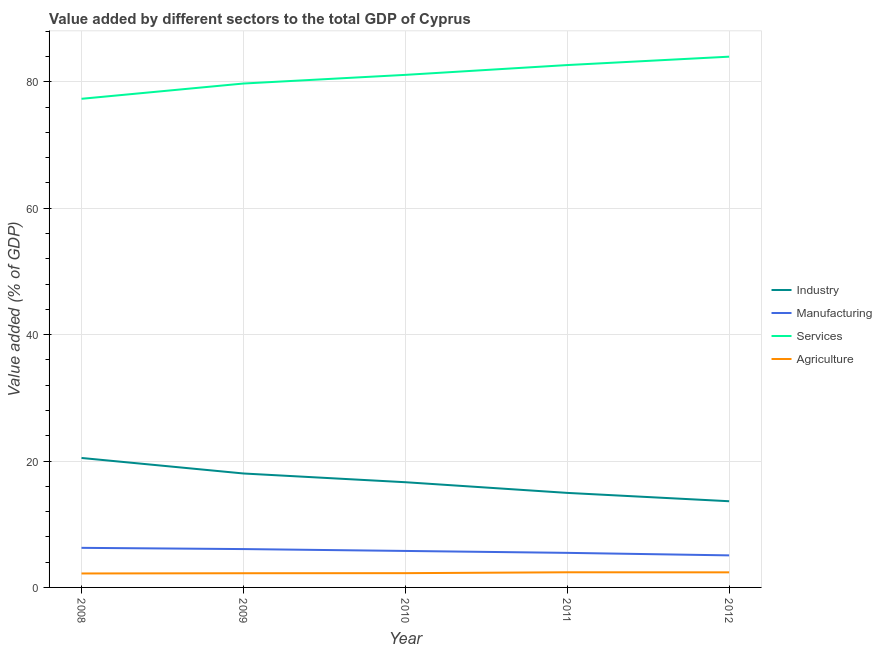How many different coloured lines are there?
Provide a short and direct response. 4. Is the number of lines equal to the number of legend labels?
Your answer should be compact. Yes. What is the value added by industrial sector in 2011?
Offer a terse response. 14.96. Across all years, what is the maximum value added by industrial sector?
Keep it short and to the point. 20.48. Across all years, what is the minimum value added by services sector?
Ensure brevity in your answer.  77.31. What is the total value added by services sector in the graph?
Make the answer very short. 404.76. What is the difference between the value added by services sector in 2011 and that in 2012?
Ensure brevity in your answer.  -1.33. What is the difference between the value added by services sector in 2009 and the value added by manufacturing sector in 2012?
Offer a very short reply. 74.65. What is the average value added by industrial sector per year?
Provide a succinct answer. 16.75. In the year 2008, what is the difference between the value added by manufacturing sector and value added by services sector?
Ensure brevity in your answer.  -71.05. What is the ratio of the value added by industrial sector in 2008 to that in 2012?
Make the answer very short. 1.5. What is the difference between the highest and the second highest value added by industrial sector?
Your answer should be very brief. 2.45. What is the difference between the highest and the lowest value added by manufacturing sector?
Offer a very short reply. 1.19. In how many years, is the value added by industrial sector greater than the average value added by industrial sector taken over all years?
Keep it short and to the point. 2. Is it the case that in every year, the sum of the value added by industrial sector and value added by manufacturing sector is greater than the value added by services sector?
Provide a short and direct response. No. Is the value added by manufacturing sector strictly greater than the value added by industrial sector over the years?
Provide a short and direct response. No. Is the value added by manufacturing sector strictly less than the value added by agricultural sector over the years?
Your answer should be very brief. No. How many lines are there?
Provide a short and direct response. 4. How many years are there in the graph?
Your answer should be compact. 5. What is the difference between two consecutive major ticks on the Y-axis?
Ensure brevity in your answer.  20. Does the graph contain grids?
Your answer should be very brief. Yes. Where does the legend appear in the graph?
Ensure brevity in your answer.  Center right. How many legend labels are there?
Provide a short and direct response. 4. What is the title of the graph?
Offer a very short reply. Value added by different sectors to the total GDP of Cyprus. What is the label or title of the X-axis?
Give a very brief answer. Year. What is the label or title of the Y-axis?
Your response must be concise. Value added (% of GDP). What is the Value added (% of GDP) in Industry in 2008?
Offer a terse response. 20.48. What is the Value added (% of GDP) of Manufacturing in 2008?
Give a very brief answer. 6.26. What is the Value added (% of GDP) in Services in 2008?
Give a very brief answer. 77.31. What is the Value added (% of GDP) of Agriculture in 2008?
Provide a short and direct response. 2.21. What is the Value added (% of GDP) of Industry in 2009?
Your answer should be compact. 18.03. What is the Value added (% of GDP) in Manufacturing in 2009?
Provide a short and direct response. 6.07. What is the Value added (% of GDP) of Services in 2009?
Your answer should be very brief. 79.73. What is the Value added (% of GDP) in Agriculture in 2009?
Provide a succinct answer. 2.24. What is the Value added (% of GDP) of Industry in 2010?
Give a very brief answer. 16.65. What is the Value added (% of GDP) in Manufacturing in 2010?
Make the answer very short. 5.77. What is the Value added (% of GDP) in Services in 2010?
Your answer should be very brief. 81.1. What is the Value added (% of GDP) in Agriculture in 2010?
Give a very brief answer. 2.26. What is the Value added (% of GDP) of Industry in 2011?
Provide a short and direct response. 14.96. What is the Value added (% of GDP) in Manufacturing in 2011?
Offer a very short reply. 5.47. What is the Value added (% of GDP) of Services in 2011?
Offer a very short reply. 82.65. What is the Value added (% of GDP) of Agriculture in 2011?
Your response must be concise. 2.4. What is the Value added (% of GDP) of Industry in 2012?
Your response must be concise. 13.64. What is the Value added (% of GDP) in Manufacturing in 2012?
Keep it short and to the point. 5.07. What is the Value added (% of GDP) of Services in 2012?
Your answer should be very brief. 83.98. What is the Value added (% of GDP) in Agriculture in 2012?
Ensure brevity in your answer.  2.39. Across all years, what is the maximum Value added (% of GDP) in Industry?
Give a very brief answer. 20.48. Across all years, what is the maximum Value added (% of GDP) in Manufacturing?
Keep it short and to the point. 6.26. Across all years, what is the maximum Value added (% of GDP) in Services?
Your answer should be very brief. 83.98. Across all years, what is the maximum Value added (% of GDP) of Agriculture?
Offer a very short reply. 2.4. Across all years, what is the minimum Value added (% of GDP) in Industry?
Your answer should be very brief. 13.64. Across all years, what is the minimum Value added (% of GDP) of Manufacturing?
Give a very brief answer. 5.07. Across all years, what is the minimum Value added (% of GDP) in Services?
Offer a terse response. 77.31. Across all years, what is the minimum Value added (% of GDP) of Agriculture?
Your answer should be very brief. 2.21. What is the total Value added (% of GDP) of Industry in the graph?
Provide a succinct answer. 83.75. What is the total Value added (% of GDP) in Manufacturing in the graph?
Make the answer very short. 28.65. What is the total Value added (% of GDP) in Services in the graph?
Keep it short and to the point. 404.76. What is the total Value added (% of GDP) in Agriculture in the graph?
Give a very brief answer. 11.49. What is the difference between the Value added (% of GDP) of Industry in 2008 and that in 2009?
Your answer should be compact. 2.45. What is the difference between the Value added (% of GDP) of Manufacturing in 2008 and that in 2009?
Give a very brief answer. 0.19. What is the difference between the Value added (% of GDP) of Services in 2008 and that in 2009?
Ensure brevity in your answer.  -2.42. What is the difference between the Value added (% of GDP) in Agriculture in 2008 and that in 2009?
Provide a short and direct response. -0.04. What is the difference between the Value added (% of GDP) in Industry in 2008 and that in 2010?
Your answer should be compact. 3.84. What is the difference between the Value added (% of GDP) of Manufacturing in 2008 and that in 2010?
Keep it short and to the point. 0.49. What is the difference between the Value added (% of GDP) in Services in 2008 and that in 2010?
Your response must be concise. -3.79. What is the difference between the Value added (% of GDP) in Agriculture in 2008 and that in 2010?
Make the answer very short. -0.05. What is the difference between the Value added (% of GDP) in Industry in 2008 and that in 2011?
Offer a very short reply. 5.53. What is the difference between the Value added (% of GDP) of Manufacturing in 2008 and that in 2011?
Make the answer very short. 0.79. What is the difference between the Value added (% of GDP) in Services in 2008 and that in 2011?
Offer a terse response. -5.34. What is the difference between the Value added (% of GDP) of Agriculture in 2008 and that in 2011?
Offer a very short reply. -0.19. What is the difference between the Value added (% of GDP) of Industry in 2008 and that in 2012?
Provide a succinct answer. 6.85. What is the difference between the Value added (% of GDP) in Manufacturing in 2008 and that in 2012?
Make the answer very short. 1.19. What is the difference between the Value added (% of GDP) in Services in 2008 and that in 2012?
Provide a short and direct response. -6.67. What is the difference between the Value added (% of GDP) in Agriculture in 2008 and that in 2012?
Keep it short and to the point. -0.18. What is the difference between the Value added (% of GDP) in Industry in 2009 and that in 2010?
Your answer should be very brief. 1.38. What is the difference between the Value added (% of GDP) of Manufacturing in 2009 and that in 2010?
Keep it short and to the point. 0.3. What is the difference between the Value added (% of GDP) of Services in 2009 and that in 2010?
Provide a short and direct response. -1.37. What is the difference between the Value added (% of GDP) of Agriculture in 2009 and that in 2010?
Provide a succinct answer. -0.01. What is the difference between the Value added (% of GDP) of Industry in 2009 and that in 2011?
Provide a short and direct response. 3.07. What is the difference between the Value added (% of GDP) in Manufacturing in 2009 and that in 2011?
Offer a terse response. 0.6. What is the difference between the Value added (% of GDP) in Services in 2009 and that in 2011?
Offer a very short reply. -2.92. What is the difference between the Value added (% of GDP) of Agriculture in 2009 and that in 2011?
Your response must be concise. -0.15. What is the difference between the Value added (% of GDP) of Industry in 2009 and that in 2012?
Ensure brevity in your answer.  4.39. What is the difference between the Value added (% of GDP) in Services in 2009 and that in 2012?
Give a very brief answer. -4.25. What is the difference between the Value added (% of GDP) in Agriculture in 2009 and that in 2012?
Make the answer very short. -0.14. What is the difference between the Value added (% of GDP) in Industry in 2010 and that in 2011?
Give a very brief answer. 1.69. What is the difference between the Value added (% of GDP) in Manufacturing in 2010 and that in 2011?
Your answer should be very brief. 0.3. What is the difference between the Value added (% of GDP) in Services in 2010 and that in 2011?
Provide a short and direct response. -1.55. What is the difference between the Value added (% of GDP) in Agriculture in 2010 and that in 2011?
Your response must be concise. -0.14. What is the difference between the Value added (% of GDP) of Industry in 2010 and that in 2012?
Keep it short and to the point. 3.01. What is the difference between the Value added (% of GDP) of Manufacturing in 2010 and that in 2012?
Give a very brief answer. 0.7. What is the difference between the Value added (% of GDP) of Services in 2010 and that in 2012?
Keep it short and to the point. -2.88. What is the difference between the Value added (% of GDP) of Agriculture in 2010 and that in 2012?
Make the answer very short. -0.13. What is the difference between the Value added (% of GDP) of Industry in 2011 and that in 2012?
Give a very brief answer. 1.32. What is the difference between the Value added (% of GDP) of Manufacturing in 2011 and that in 2012?
Provide a short and direct response. 0.4. What is the difference between the Value added (% of GDP) in Services in 2011 and that in 2012?
Your response must be concise. -1.33. What is the difference between the Value added (% of GDP) of Agriculture in 2011 and that in 2012?
Provide a short and direct response. 0.01. What is the difference between the Value added (% of GDP) in Industry in 2008 and the Value added (% of GDP) in Manufacturing in 2009?
Your answer should be compact. 14.41. What is the difference between the Value added (% of GDP) of Industry in 2008 and the Value added (% of GDP) of Services in 2009?
Provide a succinct answer. -59.24. What is the difference between the Value added (% of GDP) in Industry in 2008 and the Value added (% of GDP) in Agriculture in 2009?
Keep it short and to the point. 18.24. What is the difference between the Value added (% of GDP) in Manufacturing in 2008 and the Value added (% of GDP) in Services in 2009?
Make the answer very short. -73.46. What is the difference between the Value added (% of GDP) in Manufacturing in 2008 and the Value added (% of GDP) in Agriculture in 2009?
Provide a succinct answer. 4.02. What is the difference between the Value added (% of GDP) in Services in 2008 and the Value added (% of GDP) in Agriculture in 2009?
Give a very brief answer. 75.06. What is the difference between the Value added (% of GDP) of Industry in 2008 and the Value added (% of GDP) of Manufacturing in 2010?
Make the answer very short. 14.71. What is the difference between the Value added (% of GDP) in Industry in 2008 and the Value added (% of GDP) in Services in 2010?
Provide a succinct answer. -60.61. What is the difference between the Value added (% of GDP) of Industry in 2008 and the Value added (% of GDP) of Agriculture in 2010?
Provide a short and direct response. 18.23. What is the difference between the Value added (% of GDP) in Manufacturing in 2008 and the Value added (% of GDP) in Services in 2010?
Give a very brief answer. -74.83. What is the difference between the Value added (% of GDP) of Manufacturing in 2008 and the Value added (% of GDP) of Agriculture in 2010?
Provide a short and direct response. 4.01. What is the difference between the Value added (% of GDP) of Services in 2008 and the Value added (% of GDP) of Agriculture in 2010?
Provide a succinct answer. 75.05. What is the difference between the Value added (% of GDP) in Industry in 2008 and the Value added (% of GDP) in Manufacturing in 2011?
Give a very brief answer. 15.01. What is the difference between the Value added (% of GDP) of Industry in 2008 and the Value added (% of GDP) of Services in 2011?
Keep it short and to the point. -62.16. What is the difference between the Value added (% of GDP) of Industry in 2008 and the Value added (% of GDP) of Agriculture in 2011?
Your answer should be very brief. 18.09. What is the difference between the Value added (% of GDP) in Manufacturing in 2008 and the Value added (% of GDP) in Services in 2011?
Your response must be concise. -76.38. What is the difference between the Value added (% of GDP) in Manufacturing in 2008 and the Value added (% of GDP) in Agriculture in 2011?
Keep it short and to the point. 3.87. What is the difference between the Value added (% of GDP) of Services in 2008 and the Value added (% of GDP) of Agriculture in 2011?
Your answer should be very brief. 74.91. What is the difference between the Value added (% of GDP) in Industry in 2008 and the Value added (% of GDP) in Manufacturing in 2012?
Give a very brief answer. 15.41. What is the difference between the Value added (% of GDP) of Industry in 2008 and the Value added (% of GDP) of Services in 2012?
Provide a short and direct response. -63.49. What is the difference between the Value added (% of GDP) in Industry in 2008 and the Value added (% of GDP) in Agriculture in 2012?
Give a very brief answer. 18.1. What is the difference between the Value added (% of GDP) in Manufacturing in 2008 and the Value added (% of GDP) in Services in 2012?
Provide a succinct answer. -77.71. What is the difference between the Value added (% of GDP) in Manufacturing in 2008 and the Value added (% of GDP) in Agriculture in 2012?
Offer a very short reply. 3.88. What is the difference between the Value added (% of GDP) in Services in 2008 and the Value added (% of GDP) in Agriculture in 2012?
Make the answer very short. 74.92. What is the difference between the Value added (% of GDP) of Industry in 2009 and the Value added (% of GDP) of Manufacturing in 2010?
Your answer should be very brief. 12.26. What is the difference between the Value added (% of GDP) in Industry in 2009 and the Value added (% of GDP) in Services in 2010?
Offer a terse response. -63.07. What is the difference between the Value added (% of GDP) of Industry in 2009 and the Value added (% of GDP) of Agriculture in 2010?
Your answer should be very brief. 15.77. What is the difference between the Value added (% of GDP) of Manufacturing in 2009 and the Value added (% of GDP) of Services in 2010?
Your response must be concise. -75.03. What is the difference between the Value added (% of GDP) in Manufacturing in 2009 and the Value added (% of GDP) in Agriculture in 2010?
Keep it short and to the point. 3.81. What is the difference between the Value added (% of GDP) of Services in 2009 and the Value added (% of GDP) of Agriculture in 2010?
Your answer should be very brief. 77.47. What is the difference between the Value added (% of GDP) of Industry in 2009 and the Value added (% of GDP) of Manufacturing in 2011?
Offer a terse response. 12.56. What is the difference between the Value added (% of GDP) of Industry in 2009 and the Value added (% of GDP) of Services in 2011?
Your answer should be compact. -64.62. What is the difference between the Value added (% of GDP) in Industry in 2009 and the Value added (% of GDP) in Agriculture in 2011?
Your response must be concise. 15.63. What is the difference between the Value added (% of GDP) in Manufacturing in 2009 and the Value added (% of GDP) in Services in 2011?
Your answer should be compact. -76.58. What is the difference between the Value added (% of GDP) in Manufacturing in 2009 and the Value added (% of GDP) in Agriculture in 2011?
Provide a succinct answer. 3.67. What is the difference between the Value added (% of GDP) in Services in 2009 and the Value added (% of GDP) in Agriculture in 2011?
Provide a short and direct response. 77.33. What is the difference between the Value added (% of GDP) of Industry in 2009 and the Value added (% of GDP) of Manufacturing in 2012?
Your answer should be compact. 12.96. What is the difference between the Value added (% of GDP) of Industry in 2009 and the Value added (% of GDP) of Services in 2012?
Keep it short and to the point. -65.95. What is the difference between the Value added (% of GDP) of Industry in 2009 and the Value added (% of GDP) of Agriculture in 2012?
Make the answer very short. 15.64. What is the difference between the Value added (% of GDP) of Manufacturing in 2009 and the Value added (% of GDP) of Services in 2012?
Offer a terse response. -77.91. What is the difference between the Value added (% of GDP) of Manufacturing in 2009 and the Value added (% of GDP) of Agriculture in 2012?
Your answer should be compact. 3.68. What is the difference between the Value added (% of GDP) in Services in 2009 and the Value added (% of GDP) in Agriculture in 2012?
Give a very brief answer. 77.34. What is the difference between the Value added (% of GDP) of Industry in 2010 and the Value added (% of GDP) of Manufacturing in 2011?
Provide a succinct answer. 11.18. What is the difference between the Value added (% of GDP) in Industry in 2010 and the Value added (% of GDP) in Services in 2011?
Your answer should be very brief. -66. What is the difference between the Value added (% of GDP) of Industry in 2010 and the Value added (% of GDP) of Agriculture in 2011?
Offer a terse response. 14.25. What is the difference between the Value added (% of GDP) in Manufacturing in 2010 and the Value added (% of GDP) in Services in 2011?
Ensure brevity in your answer.  -76.87. What is the difference between the Value added (% of GDP) in Manufacturing in 2010 and the Value added (% of GDP) in Agriculture in 2011?
Your response must be concise. 3.38. What is the difference between the Value added (% of GDP) in Services in 2010 and the Value added (% of GDP) in Agriculture in 2011?
Give a very brief answer. 78.7. What is the difference between the Value added (% of GDP) of Industry in 2010 and the Value added (% of GDP) of Manufacturing in 2012?
Offer a very short reply. 11.58. What is the difference between the Value added (% of GDP) of Industry in 2010 and the Value added (% of GDP) of Services in 2012?
Your response must be concise. -67.33. What is the difference between the Value added (% of GDP) in Industry in 2010 and the Value added (% of GDP) in Agriculture in 2012?
Your response must be concise. 14.26. What is the difference between the Value added (% of GDP) of Manufacturing in 2010 and the Value added (% of GDP) of Services in 2012?
Your answer should be very brief. -78.2. What is the difference between the Value added (% of GDP) of Manufacturing in 2010 and the Value added (% of GDP) of Agriculture in 2012?
Ensure brevity in your answer.  3.39. What is the difference between the Value added (% of GDP) of Services in 2010 and the Value added (% of GDP) of Agriculture in 2012?
Your response must be concise. 78.71. What is the difference between the Value added (% of GDP) in Industry in 2011 and the Value added (% of GDP) in Manufacturing in 2012?
Your answer should be compact. 9.89. What is the difference between the Value added (% of GDP) in Industry in 2011 and the Value added (% of GDP) in Services in 2012?
Your response must be concise. -69.02. What is the difference between the Value added (% of GDP) of Industry in 2011 and the Value added (% of GDP) of Agriculture in 2012?
Make the answer very short. 12.57. What is the difference between the Value added (% of GDP) in Manufacturing in 2011 and the Value added (% of GDP) in Services in 2012?
Your answer should be compact. -78.51. What is the difference between the Value added (% of GDP) of Manufacturing in 2011 and the Value added (% of GDP) of Agriculture in 2012?
Your answer should be very brief. 3.08. What is the difference between the Value added (% of GDP) of Services in 2011 and the Value added (% of GDP) of Agriculture in 2012?
Keep it short and to the point. 80.26. What is the average Value added (% of GDP) of Industry per year?
Keep it short and to the point. 16.75. What is the average Value added (% of GDP) of Manufacturing per year?
Your answer should be very brief. 5.73. What is the average Value added (% of GDP) in Services per year?
Your answer should be compact. 80.95. What is the average Value added (% of GDP) of Agriculture per year?
Your answer should be very brief. 2.3. In the year 2008, what is the difference between the Value added (% of GDP) in Industry and Value added (% of GDP) in Manufacturing?
Your answer should be compact. 14.22. In the year 2008, what is the difference between the Value added (% of GDP) of Industry and Value added (% of GDP) of Services?
Provide a succinct answer. -56.83. In the year 2008, what is the difference between the Value added (% of GDP) in Industry and Value added (% of GDP) in Agriculture?
Your answer should be compact. 18.28. In the year 2008, what is the difference between the Value added (% of GDP) in Manufacturing and Value added (% of GDP) in Services?
Offer a terse response. -71.05. In the year 2008, what is the difference between the Value added (% of GDP) of Manufacturing and Value added (% of GDP) of Agriculture?
Your answer should be very brief. 4.06. In the year 2008, what is the difference between the Value added (% of GDP) of Services and Value added (% of GDP) of Agriculture?
Keep it short and to the point. 75.1. In the year 2009, what is the difference between the Value added (% of GDP) in Industry and Value added (% of GDP) in Manufacturing?
Give a very brief answer. 11.96. In the year 2009, what is the difference between the Value added (% of GDP) of Industry and Value added (% of GDP) of Services?
Offer a terse response. -61.7. In the year 2009, what is the difference between the Value added (% of GDP) of Industry and Value added (% of GDP) of Agriculture?
Offer a terse response. 15.78. In the year 2009, what is the difference between the Value added (% of GDP) in Manufacturing and Value added (% of GDP) in Services?
Your answer should be very brief. -73.66. In the year 2009, what is the difference between the Value added (% of GDP) in Manufacturing and Value added (% of GDP) in Agriculture?
Keep it short and to the point. 3.82. In the year 2009, what is the difference between the Value added (% of GDP) of Services and Value added (% of GDP) of Agriculture?
Your answer should be very brief. 77.48. In the year 2010, what is the difference between the Value added (% of GDP) in Industry and Value added (% of GDP) in Manufacturing?
Provide a succinct answer. 10.87. In the year 2010, what is the difference between the Value added (% of GDP) in Industry and Value added (% of GDP) in Services?
Your answer should be very brief. -64.45. In the year 2010, what is the difference between the Value added (% of GDP) of Industry and Value added (% of GDP) of Agriculture?
Provide a succinct answer. 14.39. In the year 2010, what is the difference between the Value added (% of GDP) of Manufacturing and Value added (% of GDP) of Services?
Offer a very short reply. -75.32. In the year 2010, what is the difference between the Value added (% of GDP) in Manufacturing and Value added (% of GDP) in Agriculture?
Offer a very short reply. 3.52. In the year 2010, what is the difference between the Value added (% of GDP) of Services and Value added (% of GDP) of Agriculture?
Make the answer very short. 78.84. In the year 2011, what is the difference between the Value added (% of GDP) in Industry and Value added (% of GDP) in Manufacturing?
Ensure brevity in your answer.  9.49. In the year 2011, what is the difference between the Value added (% of GDP) of Industry and Value added (% of GDP) of Services?
Offer a terse response. -67.69. In the year 2011, what is the difference between the Value added (% of GDP) of Industry and Value added (% of GDP) of Agriculture?
Make the answer very short. 12.56. In the year 2011, what is the difference between the Value added (% of GDP) in Manufacturing and Value added (% of GDP) in Services?
Offer a terse response. -77.18. In the year 2011, what is the difference between the Value added (% of GDP) of Manufacturing and Value added (% of GDP) of Agriculture?
Offer a terse response. 3.07. In the year 2011, what is the difference between the Value added (% of GDP) in Services and Value added (% of GDP) in Agriculture?
Offer a very short reply. 80.25. In the year 2012, what is the difference between the Value added (% of GDP) in Industry and Value added (% of GDP) in Manufacturing?
Your answer should be very brief. 8.57. In the year 2012, what is the difference between the Value added (% of GDP) of Industry and Value added (% of GDP) of Services?
Offer a terse response. -70.34. In the year 2012, what is the difference between the Value added (% of GDP) of Industry and Value added (% of GDP) of Agriculture?
Provide a short and direct response. 11.25. In the year 2012, what is the difference between the Value added (% of GDP) in Manufacturing and Value added (% of GDP) in Services?
Make the answer very short. -78.9. In the year 2012, what is the difference between the Value added (% of GDP) of Manufacturing and Value added (% of GDP) of Agriculture?
Your answer should be compact. 2.69. In the year 2012, what is the difference between the Value added (% of GDP) of Services and Value added (% of GDP) of Agriculture?
Your answer should be very brief. 81.59. What is the ratio of the Value added (% of GDP) in Industry in 2008 to that in 2009?
Ensure brevity in your answer.  1.14. What is the ratio of the Value added (% of GDP) in Manufacturing in 2008 to that in 2009?
Provide a short and direct response. 1.03. What is the ratio of the Value added (% of GDP) in Services in 2008 to that in 2009?
Ensure brevity in your answer.  0.97. What is the ratio of the Value added (% of GDP) of Agriculture in 2008 to that in 2009?
Keep it short and to the point. 0.98. What is the ratio of the Value added (% of GDP) of Industry in 2008 to that in 2010?
Provide a short and direct response. 1.23. What is the ratio of the Value added (% of GDP) of Manufacturing in 2008 to that in 2010?
Keep it short and to the point. 1.08. What is the ratio of the Value added (% of GDP) in Services in 2008 to that in 2010?
Make the answer very short. 0.95. What is the ratio of the Value added (% of GDP) of Agriculture in 2008 to that in 2010?
Your answer should be compact. 0.98. What is the ratio of the Value added (% of GDP) in Industry in 2008 to that in 2011?
Ensure brevity in your answer.  1.37. What is the ratio of the Value added (% of GDP) of Manufacturing in 2008 to that in 2011?
Make the answer very short. 1.14. What is the ratio of the Value added (% of GDP) in Services in 2008 to that in 2011?
Your response must be concise. 0.94. What is the ratio of the Value added (% of GDP) in Agriculture in 2008 to that in 2011?
Your response must be concise. 0.92. What is the ratio of the Value added (% of GDP) in Industry in 2008 to that in 2012?
Provide a succinct answer. 1.5. What is the ratio of the Value added (% of GDP) of Manufacturing in 2008 to that in 2012?
Give a very brief answer. 1.23. What is the ratio of the Value added (% of GDP) of Services in 2008 to that in 2012?
Ensure brevity in your answer.  0.92. What is the ratio of the Value added (% of GDP) of Agriculture in 2008 to that in 2012?
Give a very brief answer. 0.92. What is the ratio of the Value added (% of GDP) of Industry in 2009 to that in 2010?
Offer a very short reply. 1.08. What is the ratio of the Value added (% of GDP) of Manufacturing in 2009 to that in 2010?
Provide a short and direct response. 1.05. What is the ratio of the Value added (% of GDP) in Services in 2009 to that in 2010?
Make the answer very short. 0.98. What is the ratio of the Value added (% of GDP) in Agriculture in 2009 to that in 2010?
Keep it short and to the point. 0.99. What is the ratio of the Value added (% of GDP) in Industry in 2009 to that in 2011?
Make the answer very short. 1.21. What is the ratio of the Value added (% of GDP) of Manufacturing in 2009 to that in 2011?
Provide a short and direct response. 1.11. What is the ratio of the Value added (% of GDP) in Services in 2009 to that in 2011?
Your answer should be very brief. 0.96. What is the ratio of the Value added (% of GDP) in Agriculture in 2009 to that in 2011?
Ensure brevity in your answer.  0.94. What is the ratio of the Value added (% of GDP) in Industry in 2009 to that in 2012?
Ensure brevity in your answer.  1.32. What is the ratio of the Value added (% of GDP) in Manufacturing in 2009 to that in 2012?
Your answer should be very brief. 1.2. What is the ratio of the Value added (% of GDP) of Services in 2009 to that in 2012?
Make the answer very short. 0.95. What is the ratio of the Value added (% of GDP) in Agriculture in 2009 to that in 2012?
Offer a very short reply. 0.94. What is the ratio of the Value added (% of GDP) in Industry in 2010 to that in 2011?
Your answer should be compact. 1.11. What is the ratio of the Value added (% of GDP) in Manufacturing in 2010 to that in 2011?
Keep it short and to the point. 1.06. What is the ratio of the Value added (% of GDP) of Services in 2010 to that in 2011?
Make the answer very short. 0.98. What is the ratio of the Value added (% of GDP) of Agriculture in 2010 to that in 2011?
Keep it short and to the point. 0.94. What is the ratio of the Value added (% of GDP) in Industry in 2010 to that in 2012?
Ensure brevity in your answer.  1.22. What is the ratio of the Value added (% of GDP) in Manufacturing in 2010 to that in 2012?
Your answer should be very brief. 1.14. What is the ratio of the Value added (% of GDP) in Services in 2010 to that in 2012?
Your response must be concise. 0.97. What is the ratio of the Value added (% of GDP) of Agriculture in 2010 to that in 2012?
Give a very brief answer. 0.95. What is the ratio of the Value added (% of GDP) of Industry in 2011 to that in 2012?
Make the answer very short. 1.1. What is the ratio of the Value added (% of GDP) in Manufacturing in 2011 to that in 2012?
Make the answer very short. 1.08. What is the ratio of the Value added (% of GDP) in Services in 2011 to that in 2012?
Your response must be concise. 0.98. What is the ratio of the Value added (% of GDP) in Agriculture in 2011 to that in 2012?
Make the answer very short. 1. What is the difference between the highest and the second highest Value added (% of GDP) of Industry?
Your answer should be compact. 2.45. What is the difference between the highest and the second highest Value added (% of GDP) of Manufacturing?
Provide a succinct answer. 0.19. What is the difference between the highest and the second highest Value added (% of GDP) of Services?
Your response must be concise. 1.33. What is the difference between the highest and the second highest Value added (% of GDP) of Agriculture?
Your answer should be compact. 0.01. What is the difference between the highest and the lowest Value added (% of GDP) in Industry?
Provide a short and direct response. 6.85. What is the difference between the highest and the lowest Value added (% of GDP) in Manufacturing?
Your answer should be compact. 1.19. What is the difference between the highest and the lowest Value added (% of GDP) of Services?
Offer a very short reply. 6.67. What is the difference between the highest and the lowest Value added (% of GDP) of Agriculture?
Ensure brevity in your answer.  0.19. 